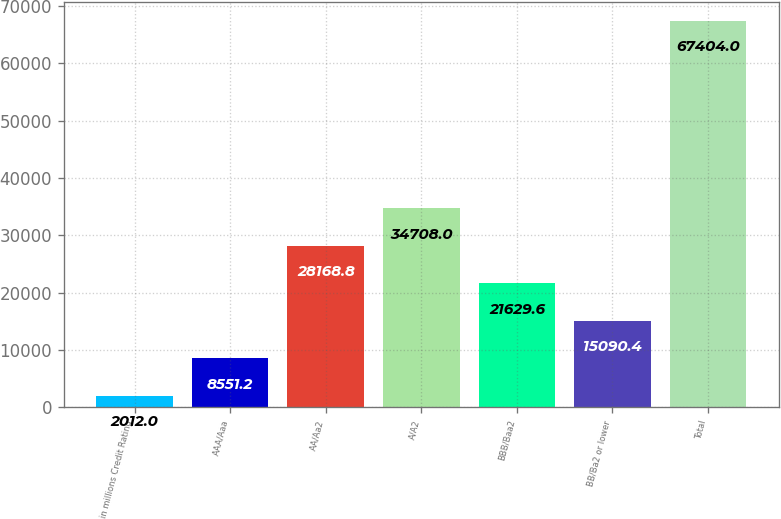<chart> <loc_0><loc_0><loc_500><loc_500><bar_chart><fcel>in millions Credit Rating<fcel>AAA/Aaa<fcel>AA/Aa2<fcel>A/A2<fcel>BBB/Baa2<fcel>BB/Ba2 or lower<fcel>Total<nl><fcel>2012<fcel>8551.2<fcel>28168.8<fcel>34708<fcel>21629.6<fcel>15090.4<fcel>67404<nl></chart> 